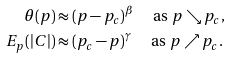<formula> <loc_0><loc_0><loc_500><loc_500>\theta ( p ) & \approx ( p - p _ { c } ) ^ { \beta } \quad \text { as } p \searrow p _ { c } , \\ E _ { p } ( | C | ) & \approx ( p _ { c } - p ) ^ { \gamma } \quad \text { as } p \nearrow p _ { c } .</formula> 